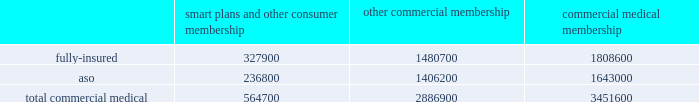We participate in a medicare health support pilot program through green ribbon health , or grh , a joint- venture company with pfizer health solutions inc .
Grh is designed to support medicare beneficiaries living with diabetes and/or congestive heart failure in central florida .
Grh uses disease management initiatives including evidence-based clinical guidelines , personal self-directed change strategies , and personal nurses to help participants navigate the health system .
Revenues under the contract with cms , which expires october 31 , 2008 unless terminated earlier , are subject to refund unless a savings target is met .
To date , all revenues have been deferred until reliable estimates are determinable .
Our products marketed to commercial segment employers and members smart plans and other consumer products over the last several years , we have developed and offered various commercial products designed to provide options and choices to employers that are annually facing substantial premium increases driven by double-digit medical cost inflation .
These smart plans , discussed more fully below , and other consumer offerings , which can be offered on either a fully-insured or aso basis , provided coverage to approximately 564700 members at december 31 , 2007 , representing approximately 16.4% ( 16.4 % ) of our total commercial medical membership as detailed below .
Smart plans and other consumer membership other commercial membership commercial medical membership .
These products are often offered to employer groups as 201cbundles 201d , where the subscribers are offered various hmo and ppo options , with various employer contribution strategies as determined by the employer .
Paramount to our product strategy , we have developed a group of innovative consumer products , styled as 201csmart 201d products , that we believe will be a long-term solution for employers .
We believe this new generation of products provides more ( 1 ) choices for the individual consumer , ( 2 ) transparency of provider costs , and ( 3 ) benefit designs that engage consumers in the costs and effectiveness of health care choices .
Innovative tools and technology are available to assist consumers with these decisions , including the trade-offs between higher premiums and point-of-service costs at the time consumers choose their plans , and to suggest ways in which the consumers can maximize their individual benefits at the point they use their plans .
We believe that when consumers can make informed choices about the cost and effectiveness of their health care , a sustainable long term solution for employers can be realized .
Smart products , which accounted for approximately 55% ( 55 % ) of enrollment in all of our consumer-choice plans as of december 31 , 2007 , are only sold to employers who use humana as their sole health insurance carrier .
Some employers have selected other types of consumer-choice products , such as , ( 1 ) a product with a high deductible , ( 2 ) a catastrophic coverage plan , or ( 3 ) ones that offer a spending account option in conjunction with more traditional medical coverage or as a stand alone plan .
Unlike our smart products , these products , while valuable in helping employers deal with near-term cost increases by shifting costs to employees , are not considered by us to be long-term comprehensive solutions to the employers 2019 cost dilemma , although we view them as an important interim step .
Our commercial hmo products provide prepaid health insurance coverage to our members through a network of independent primary care physicians , specialty physicians , and other health care providers who .
What is the percentage of aso's members among the total commercial medical membership? 
Rationale: it is the number of members of the aso plan divided by the total commercial medical membership , then turned into a percentage .
Computations: (1643000 / 3451600)
Answer: 0.47601. 